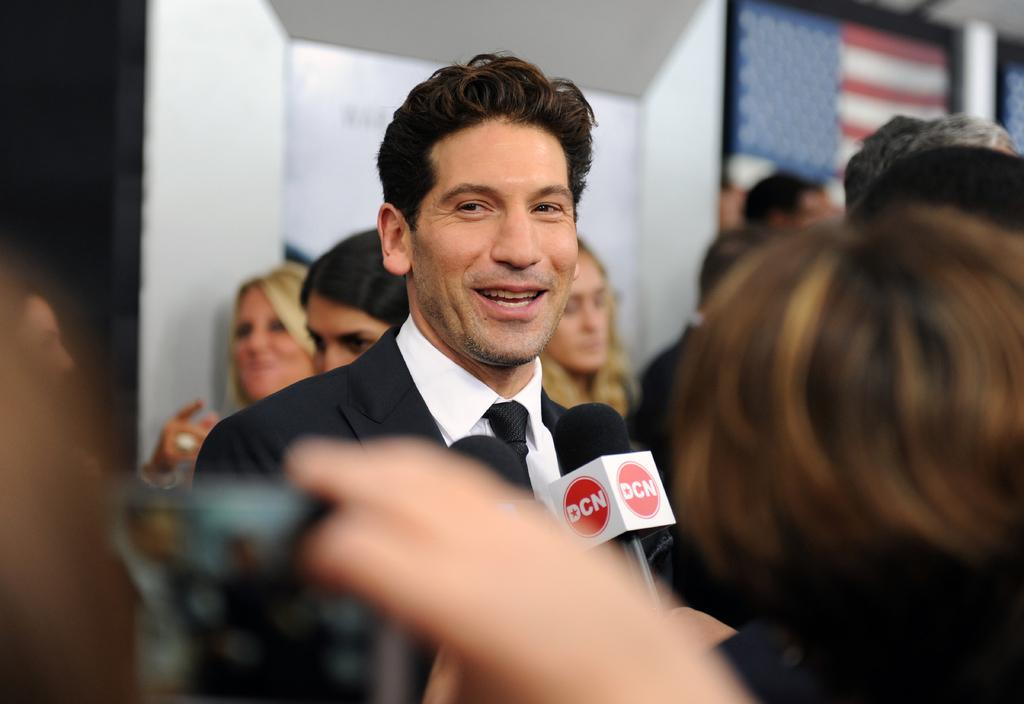Who is present in the image? There is a man in the image. What is the man doing in the image? The man is smiling in the image. What is in front of the man in the image? There are microphones in front of the man. What can be seen in the background of the image? There are people, a wall, and objects in the background of the image. How many mint leaves are on the man's shirt in the image? There are no mint leaves visible on the man's shirt in the image. 